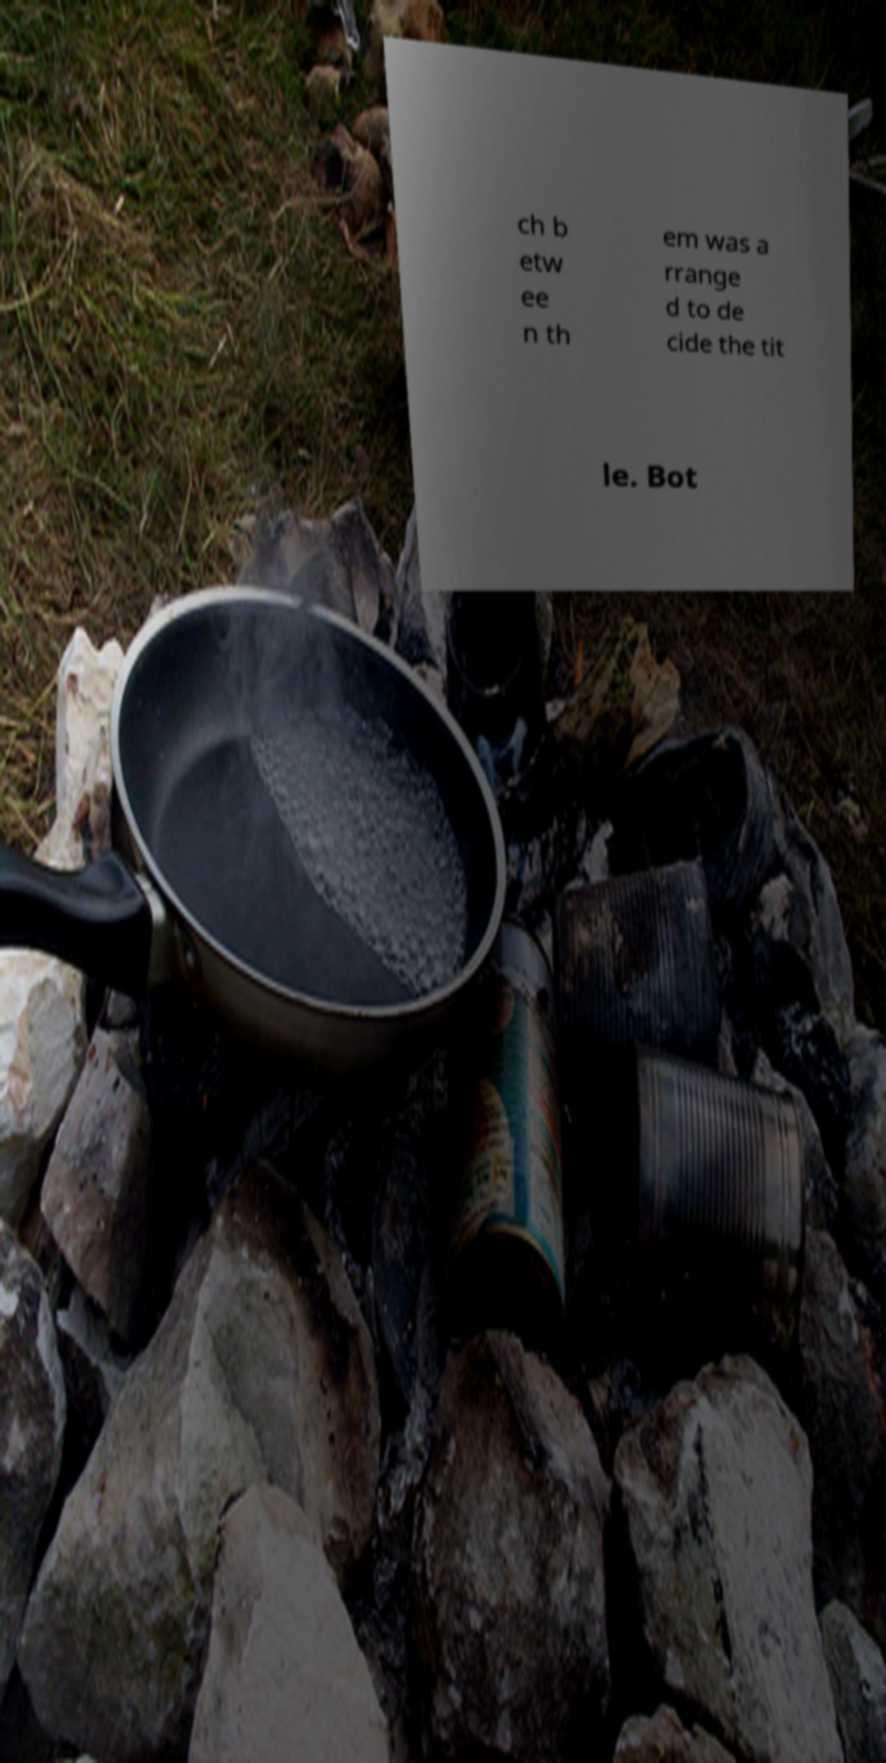I need the written content from this picture converted into text. Can you do that? ch b etw ee n th em was a rrange d to de cide the tit le. Bot 